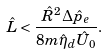Convert formula to latex. <formula><loc_0><loc_0><loc_500><loc_500>\hat { L } < \frac { \hat { R } ^ { 2 } \Delta \hat { p } _ { e } } { 8 m \hat { \eta } _ { d } \hat { U } _ { 0 } } .</formula> 